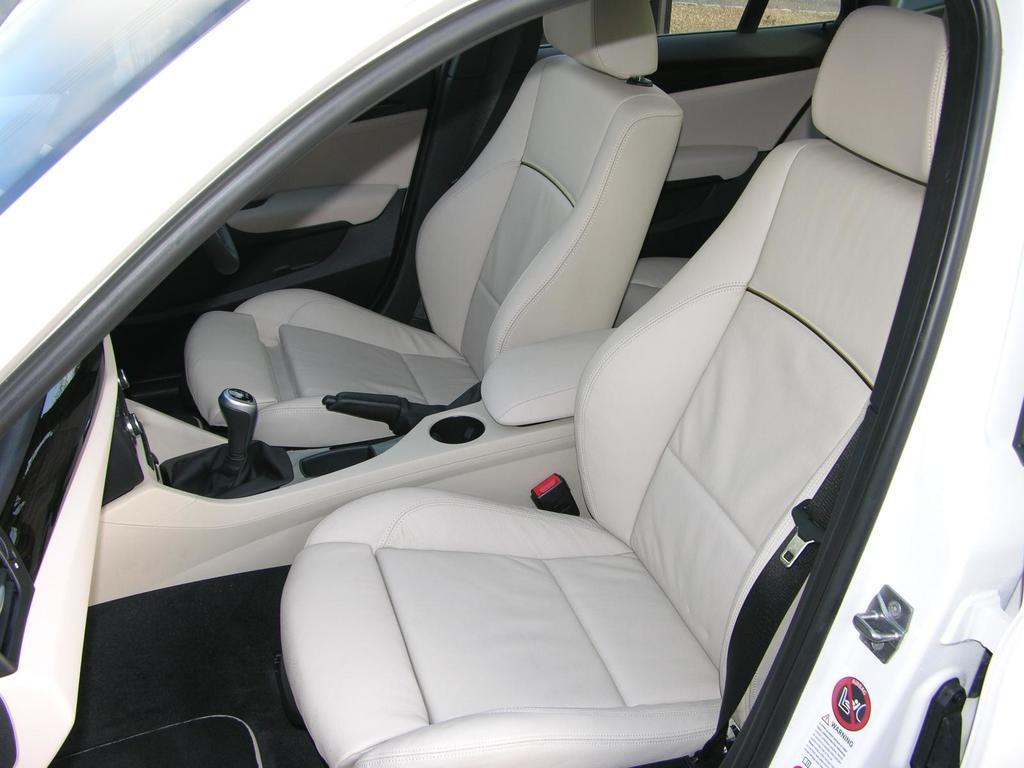What type of location is depicted in the image? The image is an inside view of a car. How many seats are visible in the image? There are two seats in the middle of the image. What can be seen behind the seats? There is a door visible behind the seats. Where is the glass located in the image? The glass is in the top left-hand corner of the image. What is the rate of the baseball being thrown in the image? There is no baseball present in the image, so it is not possible to determine the rate at which it might be thrown. 